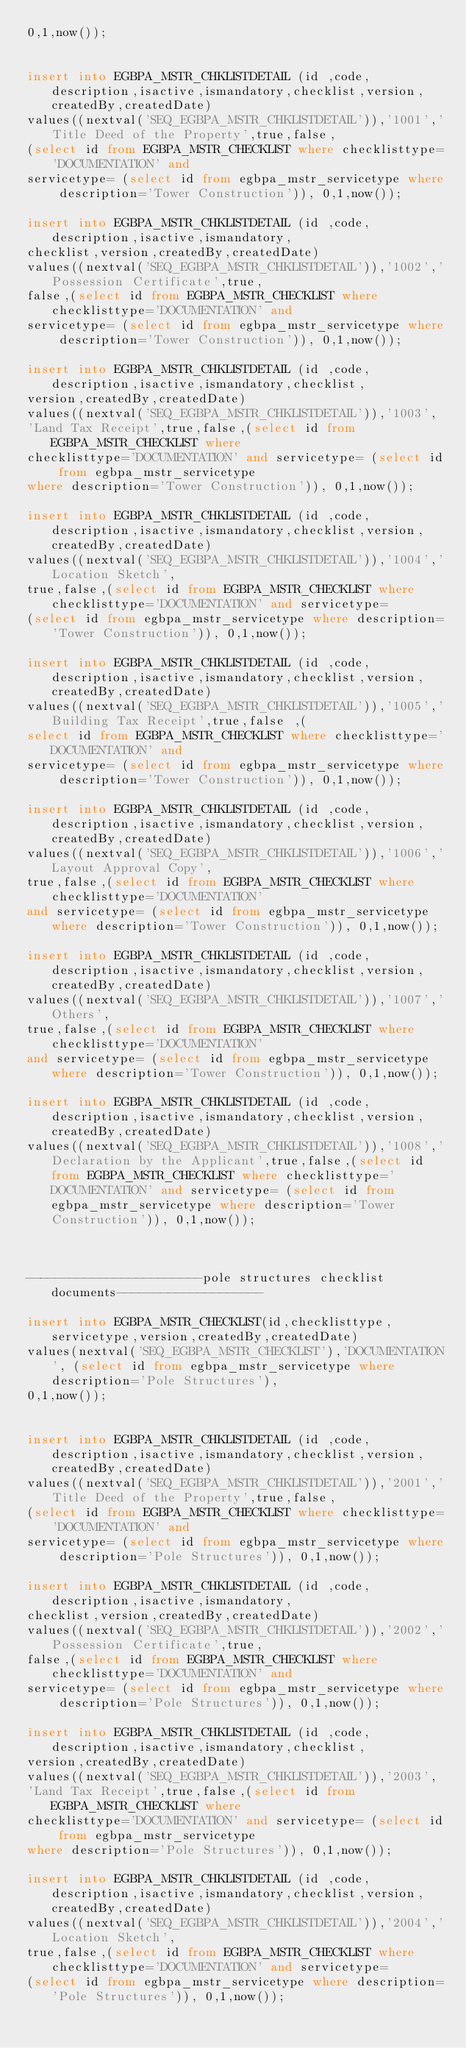<code> <loc_0><loc_0><loc_500><loc_500><_SQL_>0,1,now());


insert into EGBPA_MSTR_CHKLISTDETAIL (id ,code,description,isactive,ismandatory,checklist,version,createdBy,createdDate)
values((nextval('SEQ_EGBPA_MSTR_CHKLISTDETAIL')),'1001','Title Deed of the Property',true,false,
(select id from EGBPA_MSTR_CHECKLIST where checklisttype='DOCUMENTATION' and 
servicetype= (select id from egbpa_mstr_servicetype where description='Tower Construction')), 0,1,now());

insert into EGBPA_MSTR_CHKLISTDETAIL (id ,code,description,isactive,ismandatory,
checklist,version,createdBy,createdDate)
values((nextval('SEQ_EGBPA_MSTR_CHKLISTDETAIL')),'1002','Possession Certificate',true,
false,(select id from EGBPA_MSTR_CHECKLIST where checklisttype='DOCUMENTATION' and 
servicetype= (select id from egbpa_mstr_servicetype where description='Tower Construction')), 0,1,now());

insert into EGBPA_MSTR_CHKLISTDETAIL (id ,code,description,isactive,ismandatory,checklist,
version,createdBy,createdDate)
values((nextval('SEQ_EGBPA_MSTR_CHKLISTDETAIL')),'1003',
'Land Tax Receipt',true,false,(select id from EGBPA_MSTR_CHECKLIST where 
checklisttype='DOCUMENTATION' and servicetype= (select id from egbpa_mstr_servicetype 
where description='Tower Construction')), 0,1,now());

insert into EGBPA_MSTR_CHKLISTDETAIL (id ,code,description,isactive,ismandatory,checklist,version,createdBy,createdDate)
values((nextval('SEQ_EGBPA_MSTR_CHKLISTDETAIL')),'1004','Location Sketch',
true,false,(select id from EGBPA_MSTR_CHECKLIST where checklisttype='DOCUMENTATION' and servicetype= 
(select id from egbpa_mstr_servicetype where description='Tower Construction')), 0,1,now());

insert into EGBPA_MSTR_CHKLISTDETAIL (id ,code,description,isactive,ismandatory,checklist,version,createdBy,createdDate)
values((nextval('SEQ_EGBPA_MSTR_CHKLISTDETAIL')),'1005','Building Tax Receipt',true,false ,(
select id from EGBPA_MSTR_CHECKLIST where checklisttype='DOCUMENTATION' and 
servicetype= (select id from egbpa_mstr_servicetype where description='Tower Construction')), 0,1,now());

insert into EGBPA_MSTR_CHKLISTDETAIL (id ,code,description,isactive,ismandatory,checklist,version,createdBy,createdDate)
values((nextval('SEQ_EGBPA_MSTR_CHKLISTDETAIL')),'1006','Layout Approval Copy',
true,false,(select id from EGBPA_MSTR_CHECKLIST where checklisttype='DOCUMENTATION' 
and servicetype= (select id from egbpa_mstr_servicetype where description='Tower Construction')), 0,1,now());

insert into EGBPA_MSTR_CHKLISTDETAIL (id ,code,description,isactive,ismandatory,checklist,version,createdBy,createdDate)
values((nextval('SEQ_EGBPA_MSTR_CHKLISTDETAIL')),'1007','Others',
true,false,(select id from EGBPA_MSTR_CHECKLIST where checklisttype='DOCUMENTATION' 
and servicetype= (select id from egbpa_mstr_servicetype where description='Tower Construction')), 0,1,now());

insert into EGBPA_MSTR_CHKLISTDETAIL (id ,code,description,isactive,ismandatory,checklist,version,createdBy,createdDate)
values((nextval('SEQ_EGBPA_MSTR_CHKLISTDETAIL')),'1008','Declaration by the Applicant',true,false,(select id from EGBPA_MSTR_CHECKLIST where checklisttype='DOCUMENTATION' and servicetype= (select id from egbpa_mstr_servicetype where description='Tower Construction')), 0,1,now());



------------------------pole structures checklist documents--------------------

insert into EGBPA_MSTR_CHECKLIST(id,checklisttype,servicetype,version,createdBy,createdDate)
values(nextval('SEQ_EGBPA_MSTR_CHECKLIST'),'DOCUMENTATION', (select id from egbpa_mstr_servicetype where description='Pole Structures'),
0,1,now());


insert into EGBPA_MSTR_CHKLISTDETAIL (id ,code,description,isactive,ismandatory,checklist,version,createdBy,createdDate)
values((nextval('SEQ_EGBPA_MSTR_CHKLISTDETAIL')),'2001','Title Deed of the Property',true,false,
(select id from EGBPA_MSTR_CHECKLIST where checklisttype='DOCUMENTATION' and 
servicetype= (select id from egbpa_mstr_servicetype where description='Pole Structures')), 0,1,now());

insert into EGBPA_MSTR_CHKLISTDETAIL (id ,code,description,isactive,ismandatory,
checklist,version,createdBy,createdDate)
values((nextval('SEQ_EGBPA_MSTR_CHKLISTDETAIL')),'2002','Possession Certificate',true,
false,(select id from EGBPA_MSTR_CHECKLIST where checklisttype='DOCUMENTATION' and 
servicetype= (select id from egbpa_mstr_servicetype where description='Pole Structures')), 0,1,now());

insert into EGBPA_MSTR_CHKLISTDETAIL (id ,code,description,isactive,ismandatory,checklist,
version,createdBy,createdDate)
values((nextval('SEQ_EGBPA_MSTR_CHKLISTDETAIL')),'2003',
'Land Tax Receipt',true,false,(select id from EGBPA_MSTR_CHECKLIST where 
checklisttype='DOCUMENTATION' and servicetype= (select id from egbpa_mstr_servicetype 
where description='Pole Structures')), 0,1,now());

insert into EGBPA_MSTR_CHKLISTDETAIL (id ,code,description,isactive,ismandatory,checklist,version,createdBy,createdDate)
values((nextval('SEQ_EGBPA_MSTR_CHKLISTDETAIL')),'2004','Location Sketch',
true,false,(select id from EGBPA_MSTR_CHECKLIST where checklisttype='DOCUMENTATION' and servicetype= 
(select id from egbpa_mstr_servicetype where description='Pole Structures')), 0,1,now());
</code> 